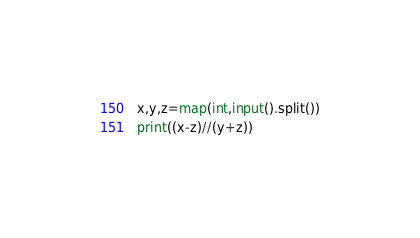Convert code to text. <code><loc_0><loc_0><loc_500><loc_500><_Python_>x,y,z=map(int,input().split())
print((x-z)//(y+z))</code> 